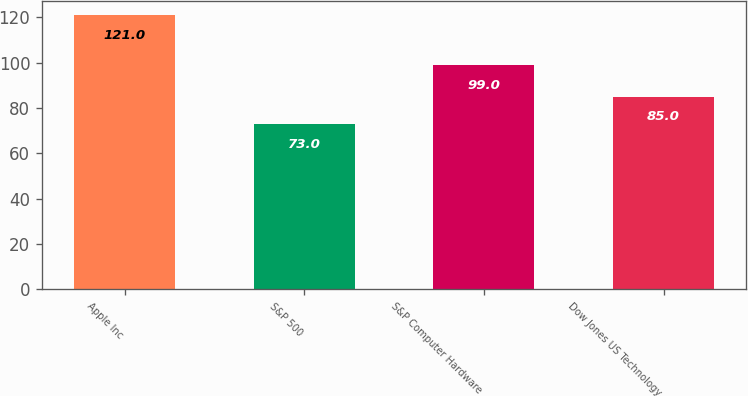<chart> <loc_0><loc_0><loc_500><loc_500><bar_chart><fcel>Apple Inc<fcel>S&P 500<fcel>S&P Computer Hardware<fcel>Dow Jones US Technology<nl><fcel>121<fcel>73<fcel>99<fcel>85<nl></chart> 